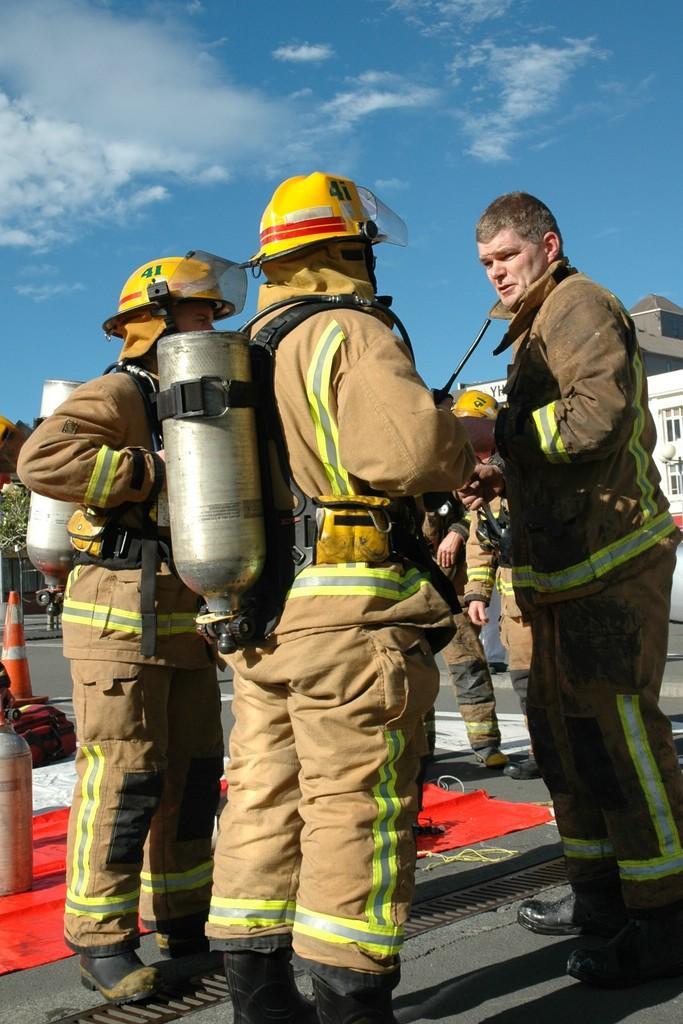Can you describe this image briefly? In this image there are persons standing in the center. On the left side there are two persons standing wearing a cylinder and yellow colour helmet. On the floor there is red colour mat and there is a cylinder on the mat. In the background there is a building which is white in colour and the sky is cloudy. On the left side there is a plant in the background. 